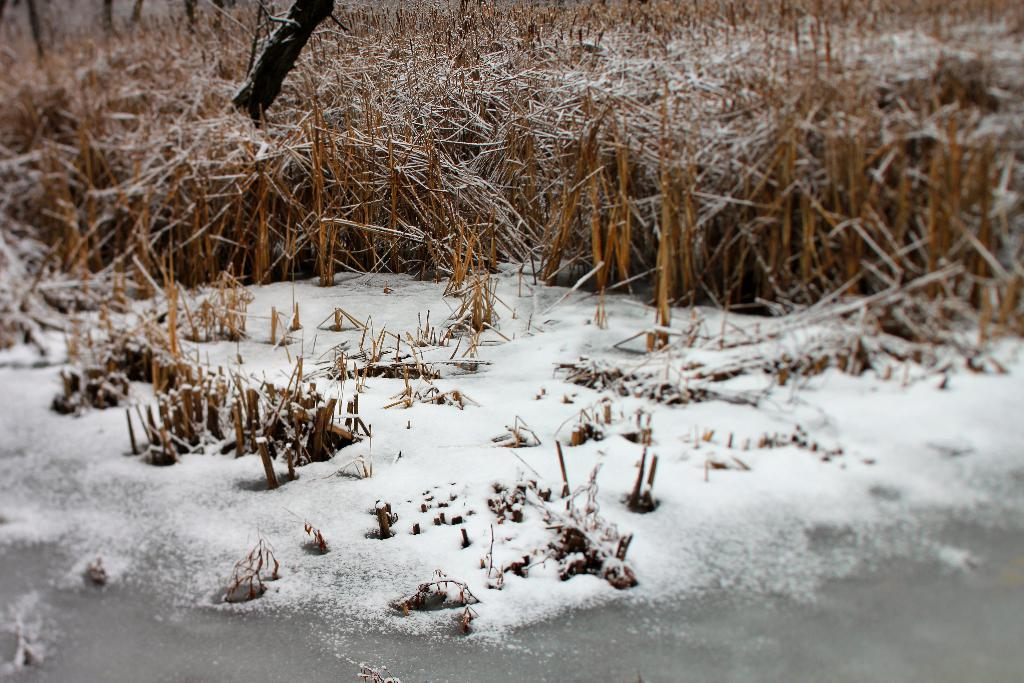What type of surface is covered with ice at the bottom of the image? There is grass covered with ice at the bottom of the image. Can you describe the grass in the background of the image? There is grass visible in the background of the image. What objects are on the left side of the image? There are wooden sticks on the left side of the image. How many apples are on the wooden sticks in the image? There is no mention of apples in the image; the objects on the left side of the image are wooden sticks. What is the cause of death depicted in the image? There is no depiction of death in the image; it features grass covered with ice and wooden sticks. 